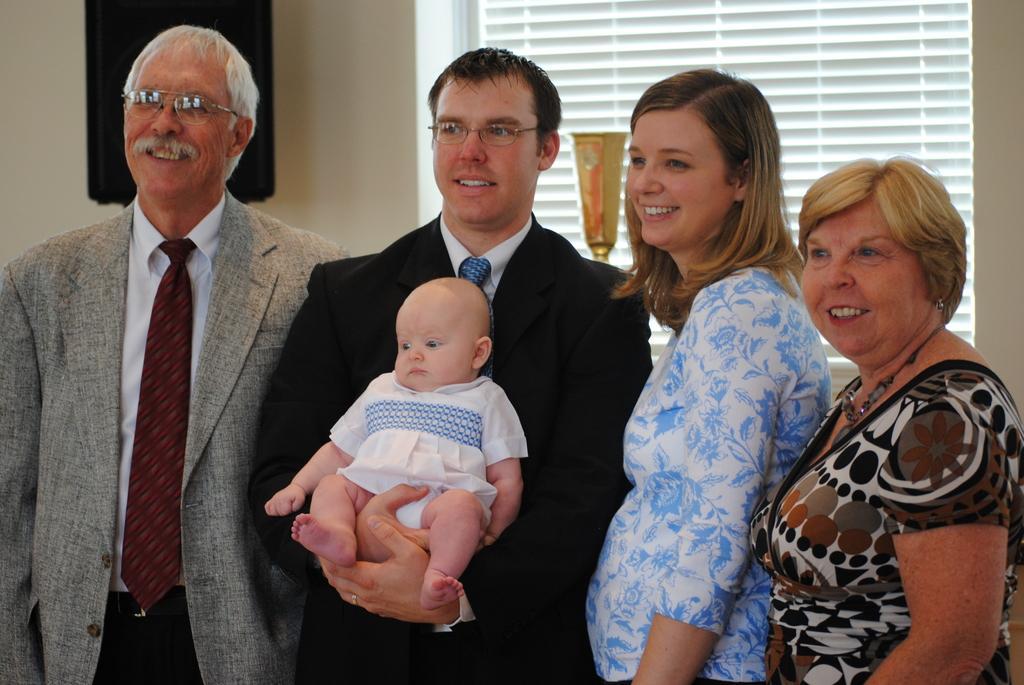Please provide a concise description of this image. In this image we can see people standing and smiling. The man standing in the center is holding a baby. In the background there is a wall and we can see blinds. There is a trophy and we can see an object. 